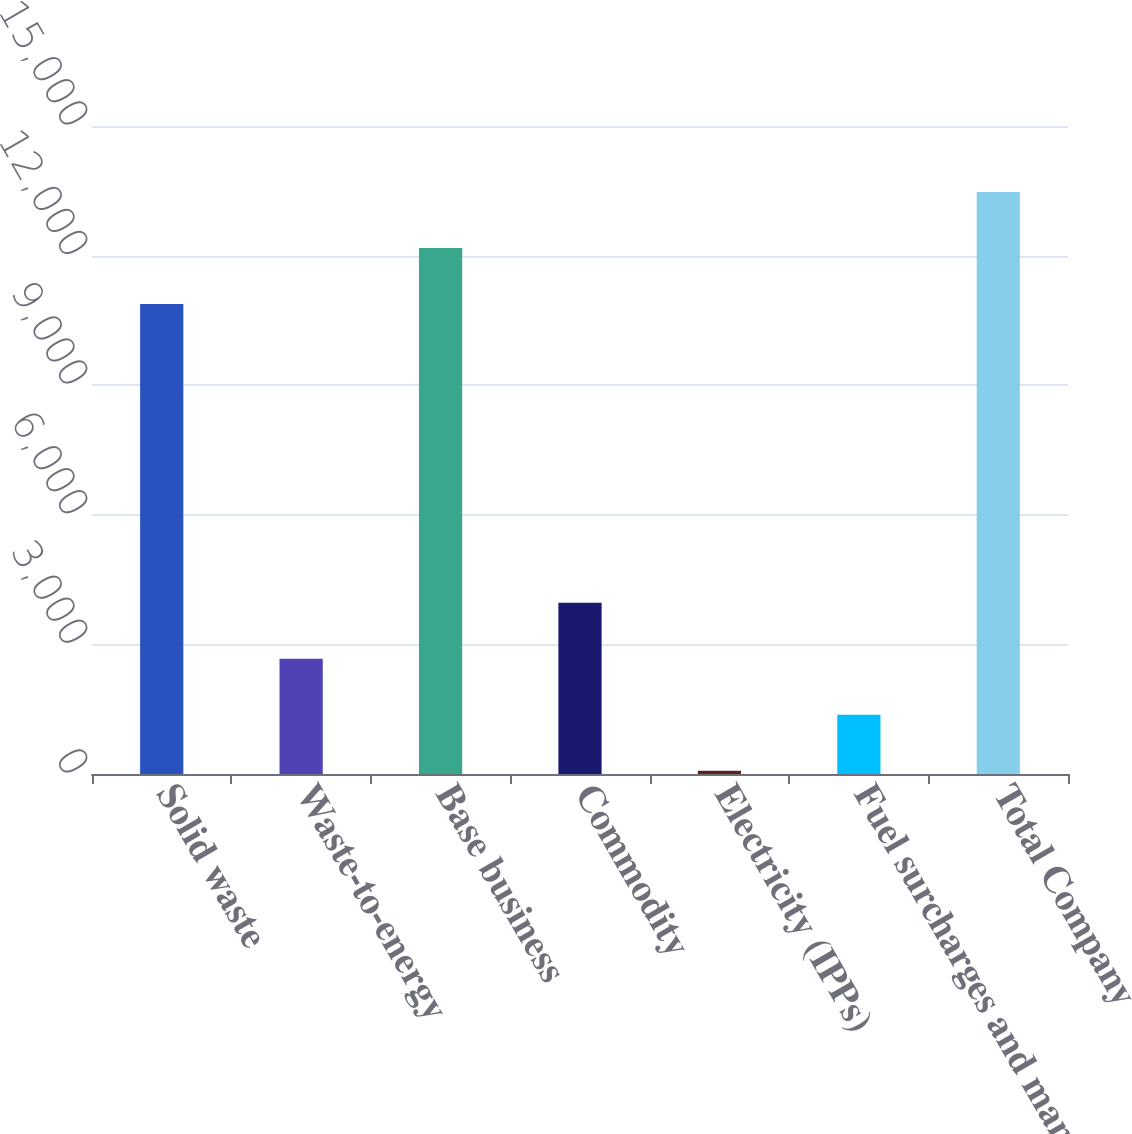Convert chart to OTSL. <chart><loc_0><loc_0><loc_500><loc_500><bar_chart><fcel>Solid waste<fcel>Waste-to-energy<fcel>Base business<fcel>Commodity<fcel>Electricity (IPPs)<fcel>Fuel surcharges and mandated<fcel>Total Company<nl><fcel>10877<fcel>2668.6<fcel>12173.8<fcel>3965.4<fcel>75<fcel>1371.8<fcel>13470.6<nl></chart> 